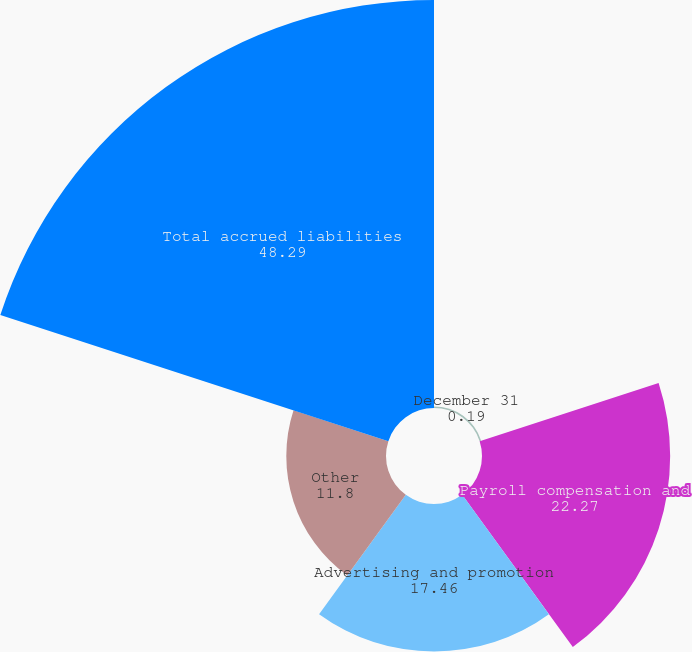Convert chart. <chart><loc_0><loc_0><loc_500><loc_500><pie_chart><fcel>December 31<fcel>Payroll compensation and<fcel>Advertising and promotion<fcel>Other<fcel>Total accrued liabilities<nl><fcel>0.19%<fcel>22.27%<fcel>17.46%<fcel>11.8%<fcel>48.29%<nl></chart> 